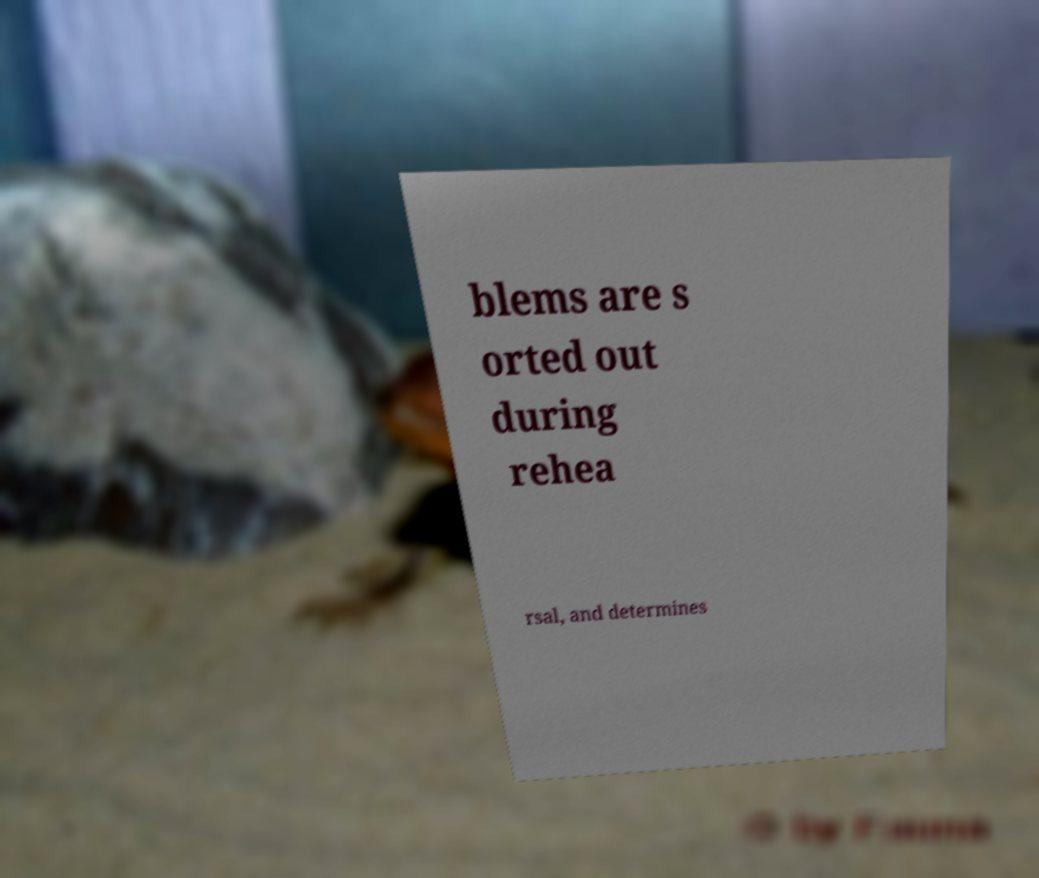Please read and relay the text visible in this image. What does it say? blems are s orted out during rehea rsal, and determines 